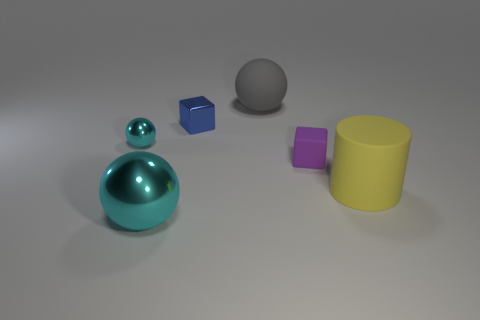How many other things are the same size as the gray object? 2 